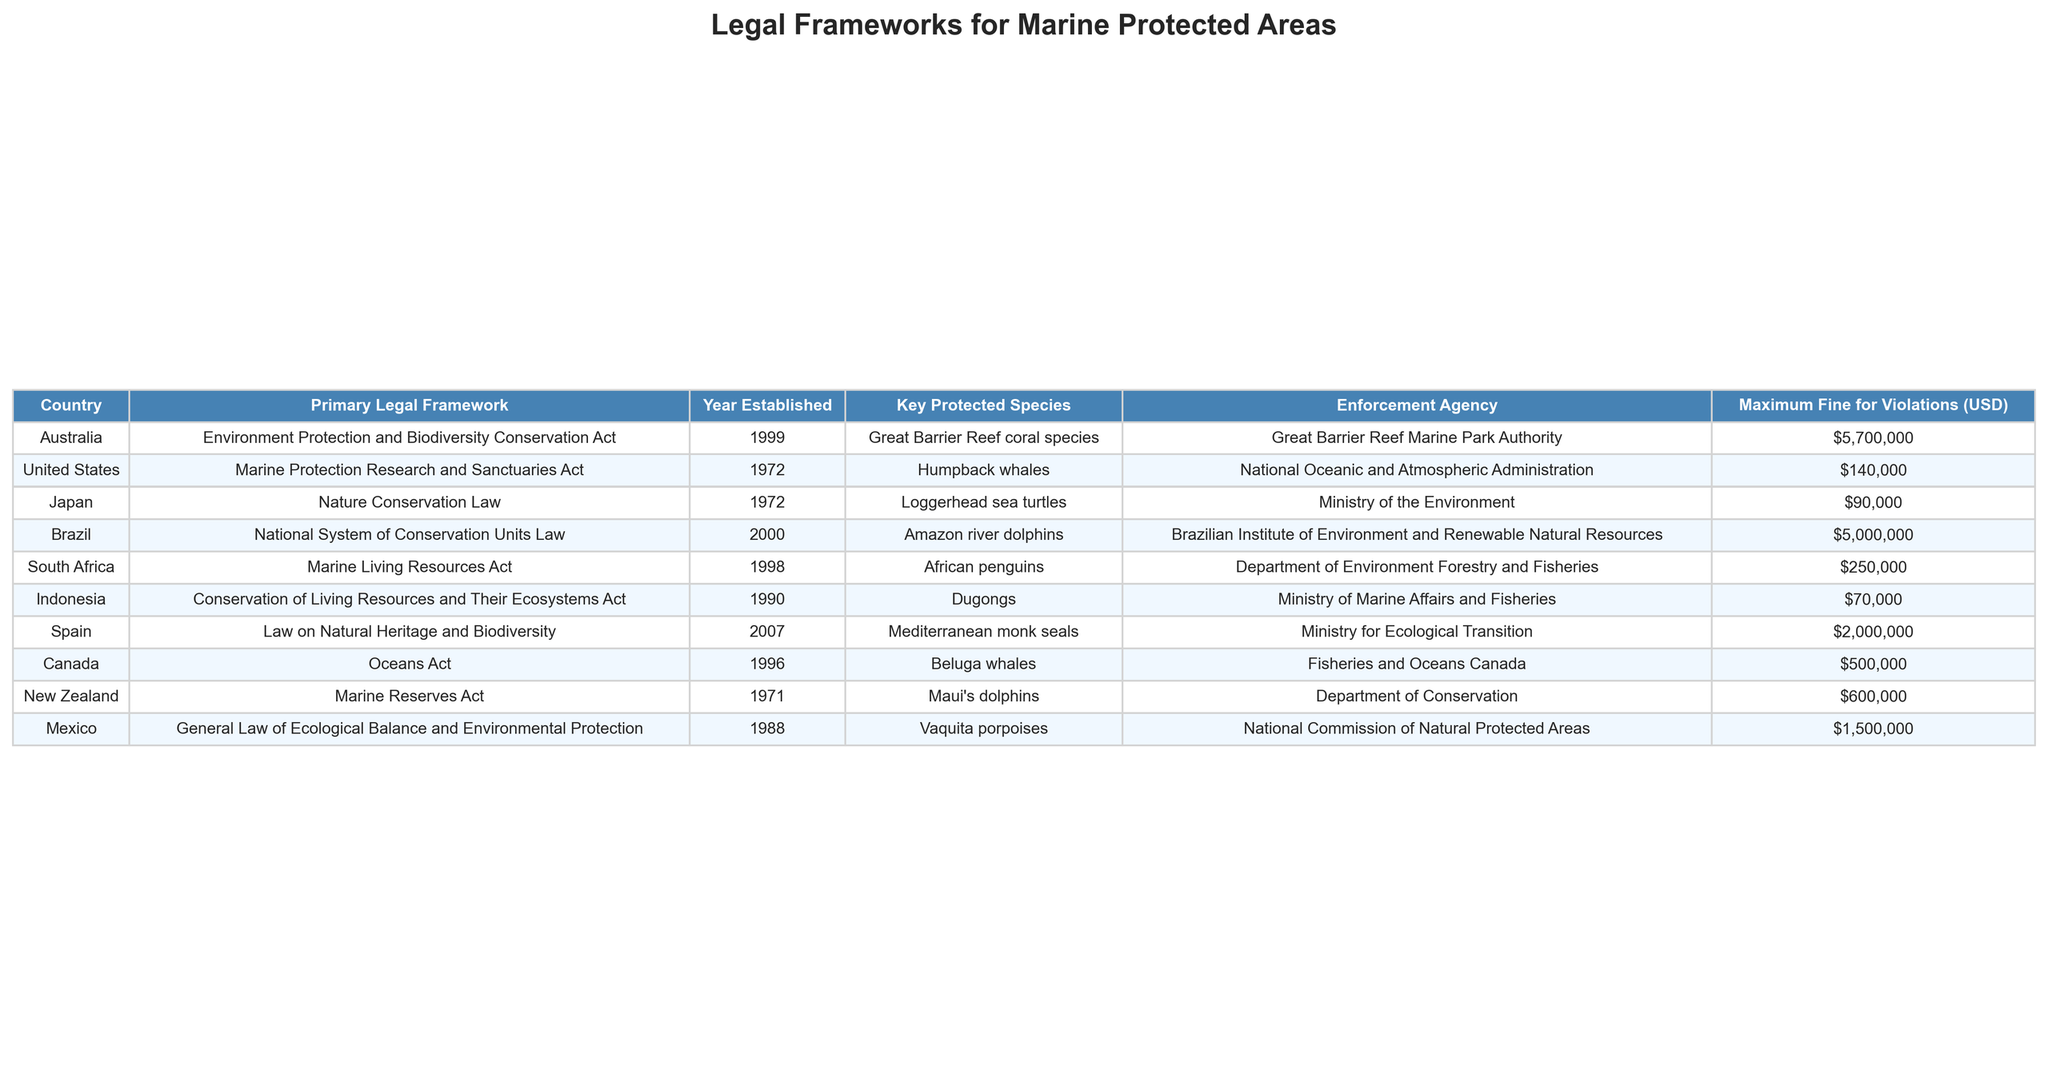What is the primary legal framework for marine protected areas in Japan? The table shows that Japan's primary legal framework is the Nature Conservation Law.
Answer: Nature Conservation Law Which country has the highest maximum fine for violations in marine protected areas? By comparing the maximum fines listed in the table, Australia has the highest fine of 5,700,000 USD.
Answer: Australia Are loggerhead sea turtles a key protected species in the United States? The table indicates that loggerhead sea turtles are not listed as a key protected species in the United States, but rather in Japan.
Answer: No What is the total maximum fine for violations in marine protected areas for Brazil and Mexico combined? The maximum fine for Brazil is 5,000,000 USD and for Mexico is 1,500,000 USD. Adding these gives 5,000,000 + 1,500,000 = 6,500,000 USD.
Answer: 6,500,000 USD Which agency oversees the protection of African penguins in South Africa? According to the table, the Department of Environment Forestry and Fisheries is responsible for overseeing the protection of African penguins in South Africa.
Answer: Department of Environment Forestry and Fisheries In which year was the Marine Reserves Act established in New Zealand? The table shows that the Marine Reserves Act in New Zealand was established in 1971.
Answer: 1971 What is the average maximum fine across all listed countries? To find the average, sum the maximum fines: 5,700,000 + 140,000 + 90,000 + 5,000,000 + 250,000 + 70,000 + 2,000,000 + 500,000 + 600,000 + 1,500,000 = 15,400,000. There are 10 countries, so the average is 15,400,000 / 10 = 1,540,000.
Answer: 1,540,000 USD Do any countries on the list have a primary legal framework established before 1970? Yes, the United States and Japan have legal frameworks that were established in 1972, which is before 1970.
Answer: Yes Which two countries have a maximum fine for violations below 100,000 USD? From the table, Japan and Indonesia have maximum fines of 90,000 USD and 70,000 USD respectively, both below 100,000 USD.
Answer: Japan and Indonesia What is the key protected species in Australia? The table states that the key protected species in Australia is the Great Barrier Reef coral species.
Answer: Great Barrier Reef coral species 